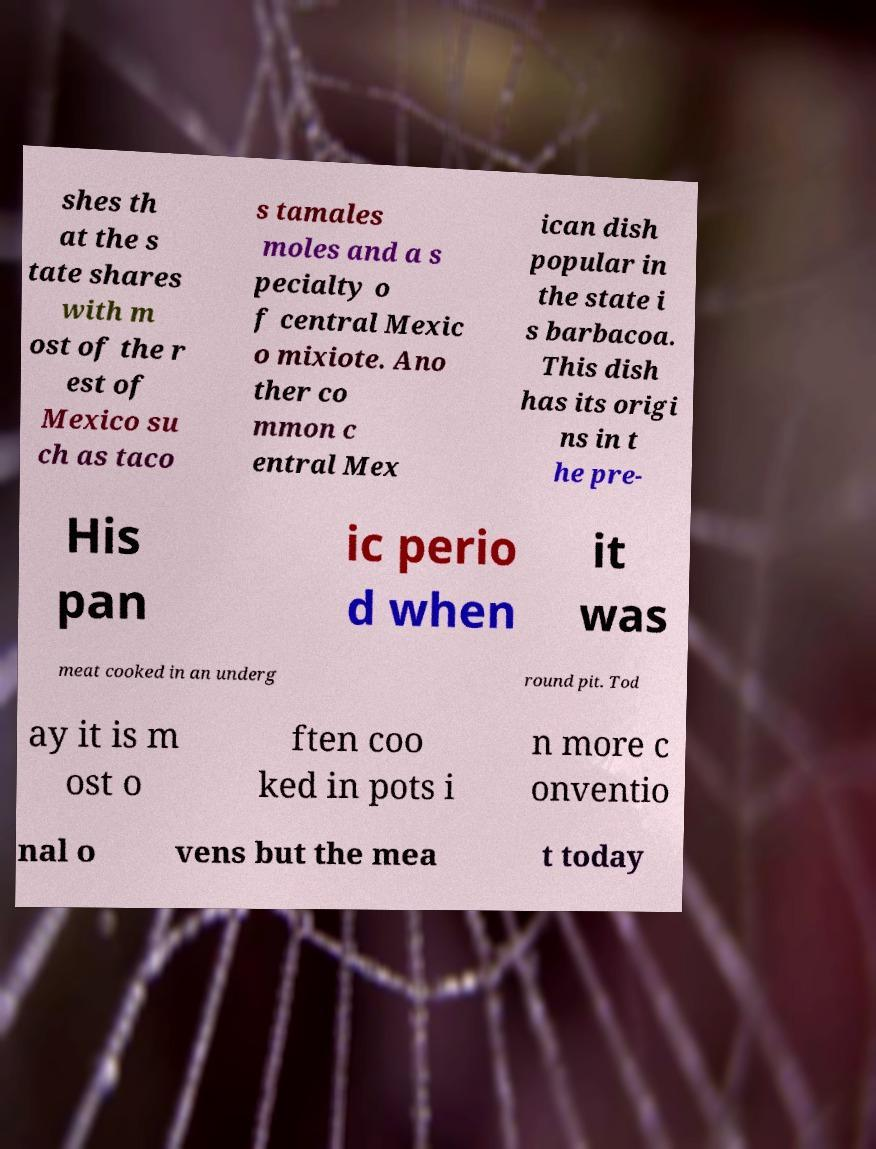Please identify and transcribe the text found in this image. shes th at the s tate shares with m ost of the r est of Mexico su ch as taco s tamales moles and a s pecialty o f central Mexic o mixiote. Ano ther co mmon c entral Mex ican dish popular in the state i s barbacoa. This dish has its origi ns in t he pre- His pan ic perio d when it was meat cooked in an underg round pit. Tod ay it is m ost o ften coo ked in pots i n more c onventio nal o vens but the mea t today 